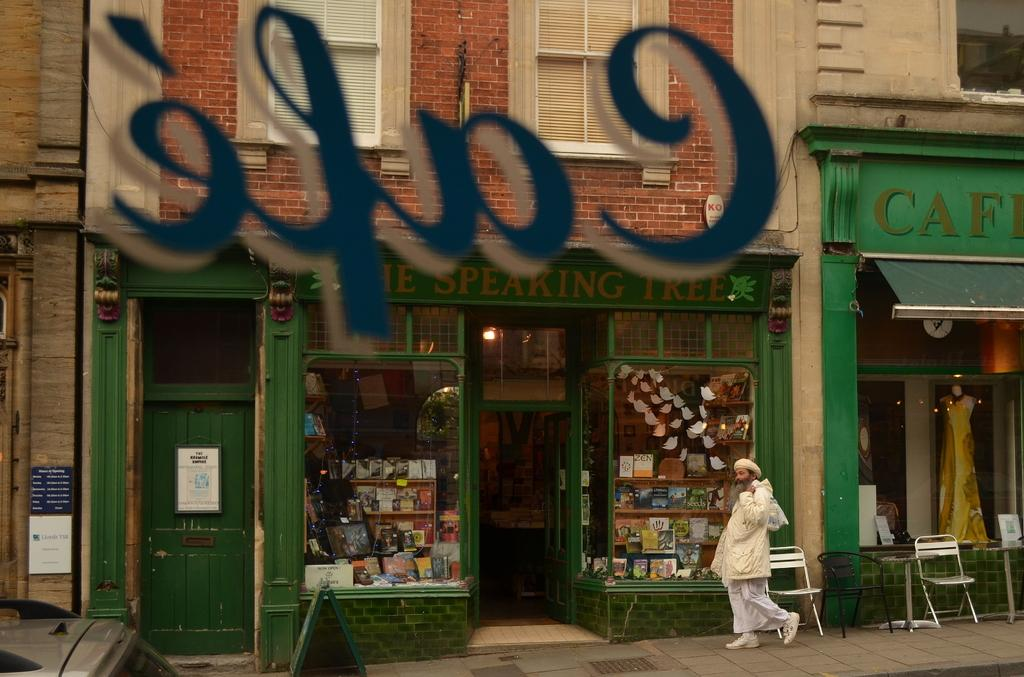<image>
Share a concise interpretation of the image provided. an image of a storefront of a cafe, with a women dressed in all white walking by. 